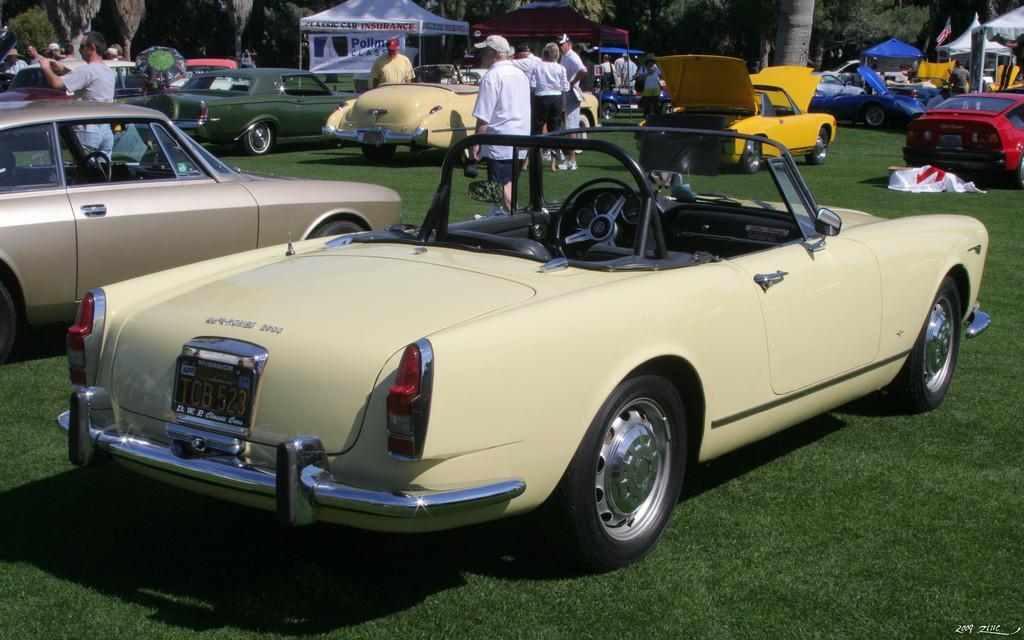In one or two sentences, can you explain what this image depicts? In this image, we can see there are vehicles in different colors on the ground, on which there is grass, there are persons and tents arranged. In the background, there are trees. 